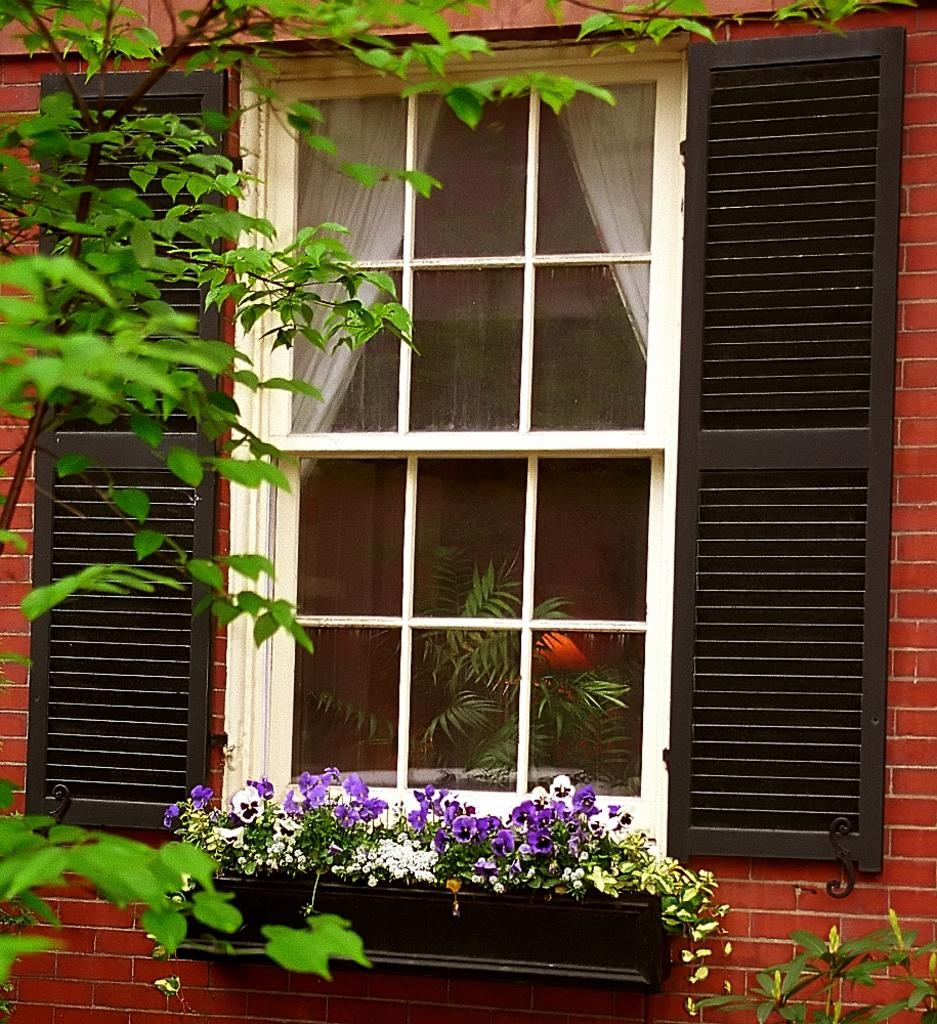What is present at the top of the image? There is a window in the image. What can be seen at the bottom of the image? There are plants at the bottom of the image. What is located on the left side of the image? There is a tree on the left side of the image. Where is the throne located in the image? There is no throne present in the image. How long does it take for the minute to pass in the image? The concept of time passing is not applicable to a still image. 